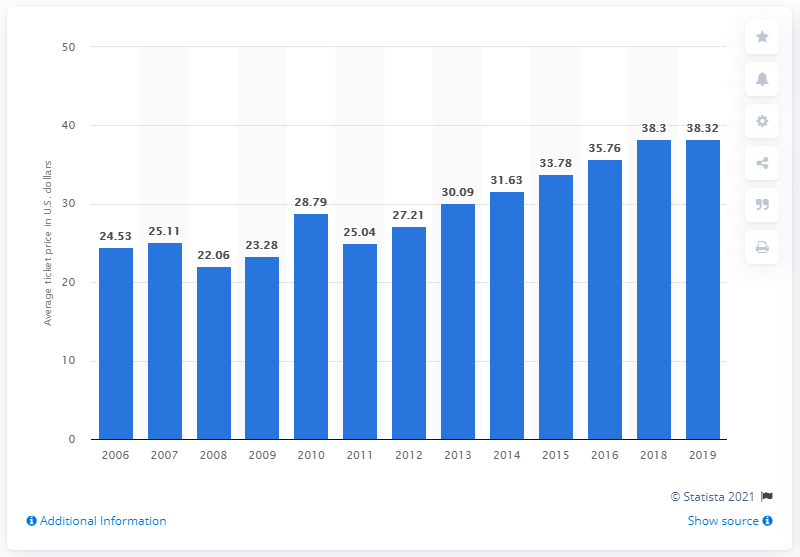Give some essential details in this illustration. The average ticket price for San Francisco Giants games in 2019 was 38.32 dollars. 